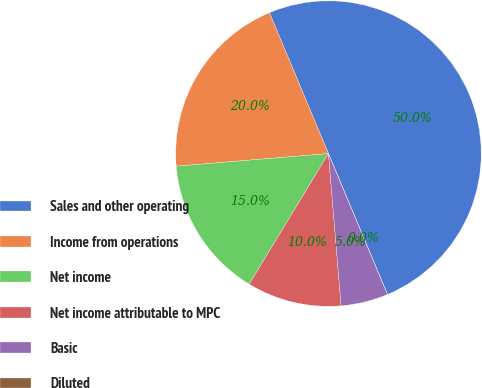Convert chart. <chart><loc_0><loc_0><loc_500><loc_500><pie_chart><fcel>Sales and other operating<fcel>Income from operations<fcel>Net income<fcel>Net income attributable to MPC<fcel>Basic<fcel>Diluted<nl><fcel>49.99%<fcel>20.0%<fcel>15.0%<fcel>10.0%<fcel>5.0%<fcel>0.0%<nl></chart> 